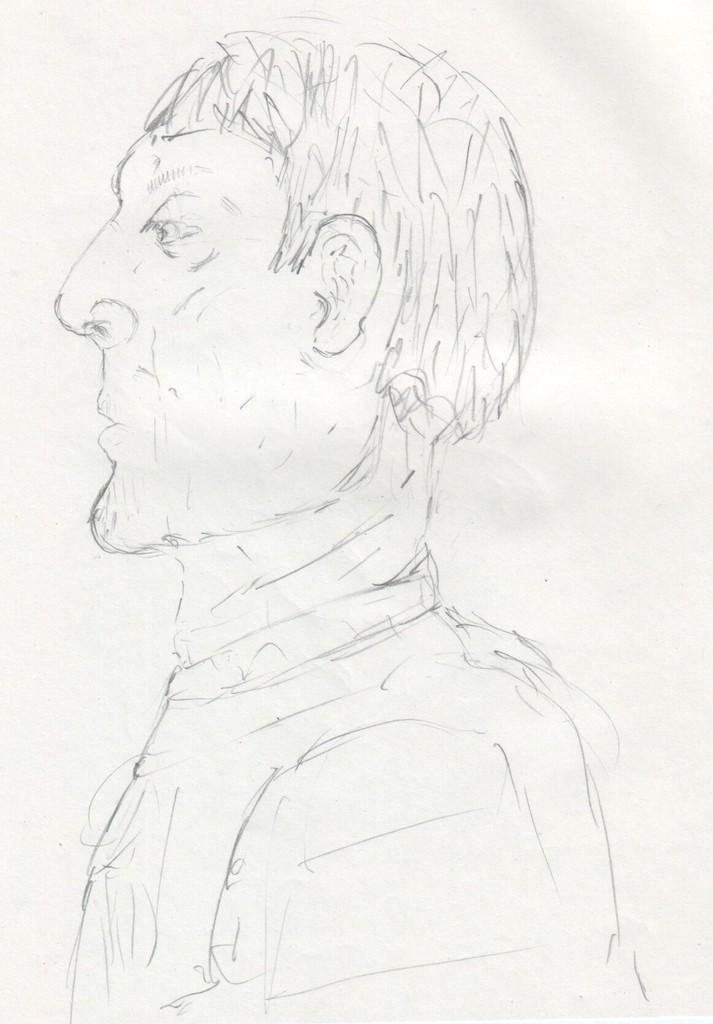What is the medium used for the art in the image? The image is on a paper, and the art is created with pencil. What is depicted in the pencil art? The pencil art contains a drawing of a person. Can you see any yaks in the pencil art? No, there are no yaks depicted in the pencil art; it features a drawing of a person. Is the person in the pencil art playing any sports or games? The provided facts do not mention any sports or games being played by the person in the pencil art. 